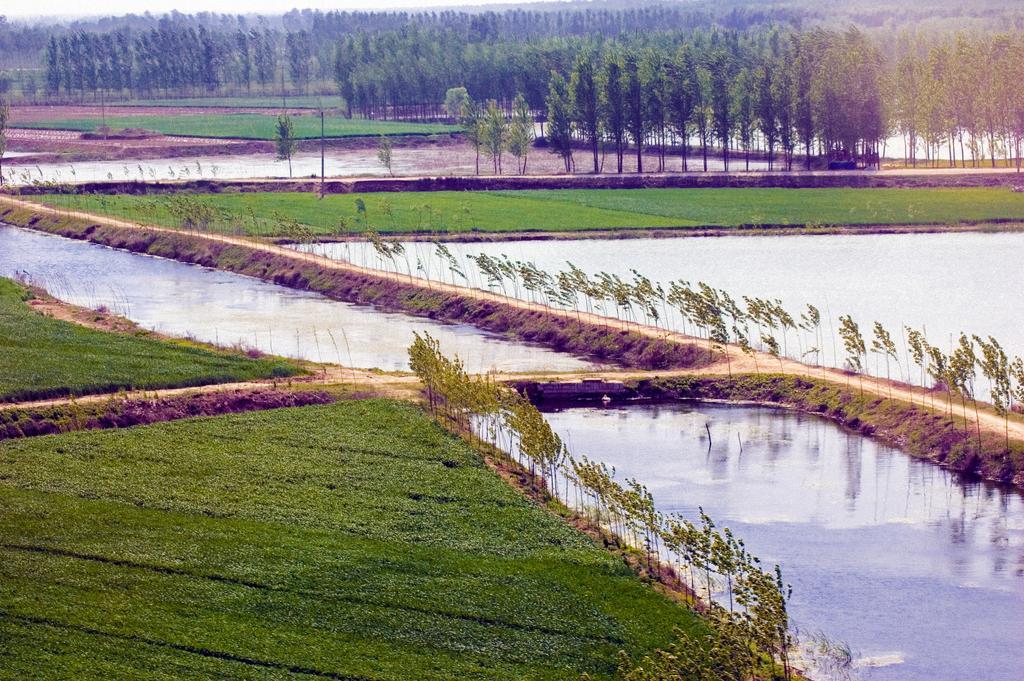Could you give a brief overview of what you see in this image? In this image, we can see some trees and ponds. There is a grass on the ground. 